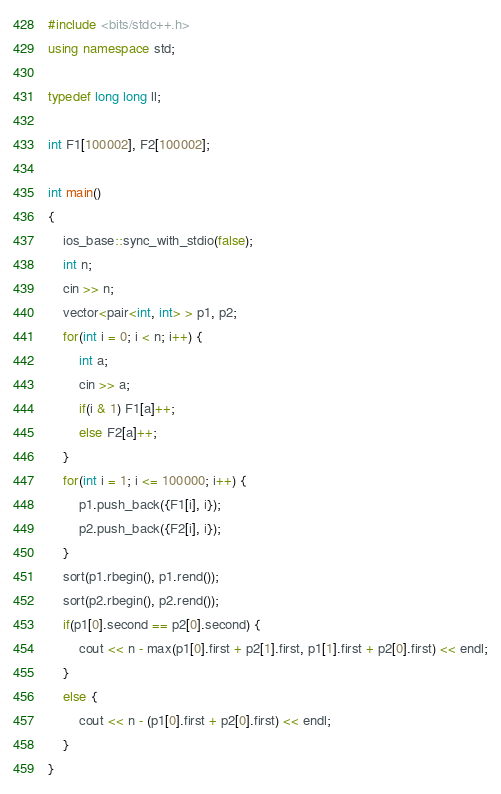Convert code to text. <code><loc_0><loc_0><loc_500><loc_500><_C++_>#include <bits/stdc++.h>
using namespace std;

typedef long long ll;

int F1[100002], F2[100002];

int main()
{
    ios_base::sync_with_stdio(false);
    int n;
    cin >> n;
    vector<pair<int, int> > p1, p2;
    for(int i = 0; i < n; i++) {
        int a;
        cin >> a;
        if(i & 1) F1[a]++;
        else F2[a]++;
    }
    for(int i = 1; i <= 100000; i++) {
        p1.push_back({F1[i], i});
        p2.push_back({F2[i], i});
    }
    sort(p1.rbegin(), p1.rend());
    sort(p2.rbegin(), p2.rend());
    if(p1[0].second == p2[0].second) {
        cout << n - max(p1[0].first + p2[1].first, p1[1].first + p2[0].first) << endl;
    }
    else {
        cout << n - (p1[0].first + p2[0].first) << endl;
    }
}
</code> 